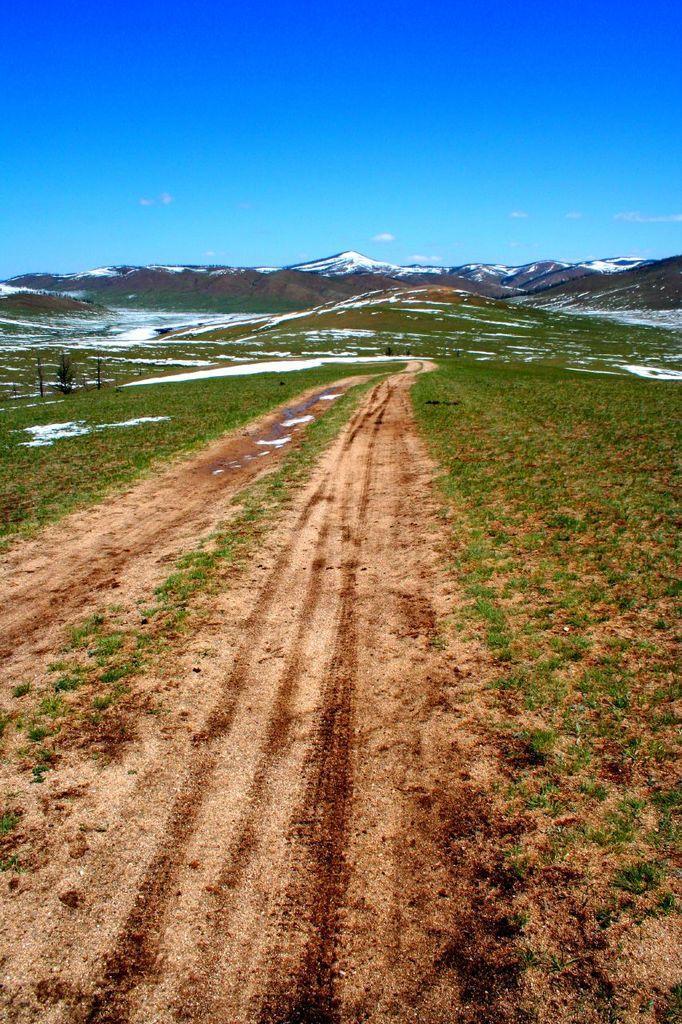Describe this image in one or two sentences. Here I can see a road. On the both sides of the road I can see the grass. In the background there are some mountains. At the top I can see the sky in blue color. 